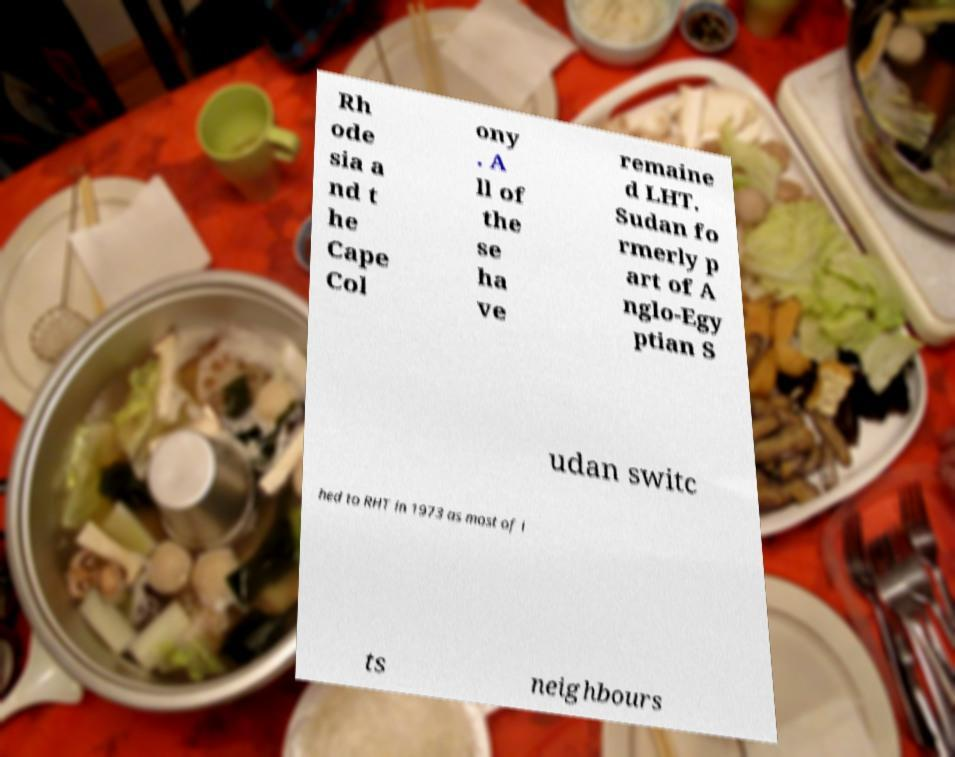Could you assist in decoding the text presented in this image and type it out clearly? Rh ode sia a nd t he Cape Col ony . A ll of the se ha ve remaine d LHT. Sudan fo rmerly p art of A nglo-Egy ptian S udan switc hed to RHT in 1973 as most of i ts neighbours 